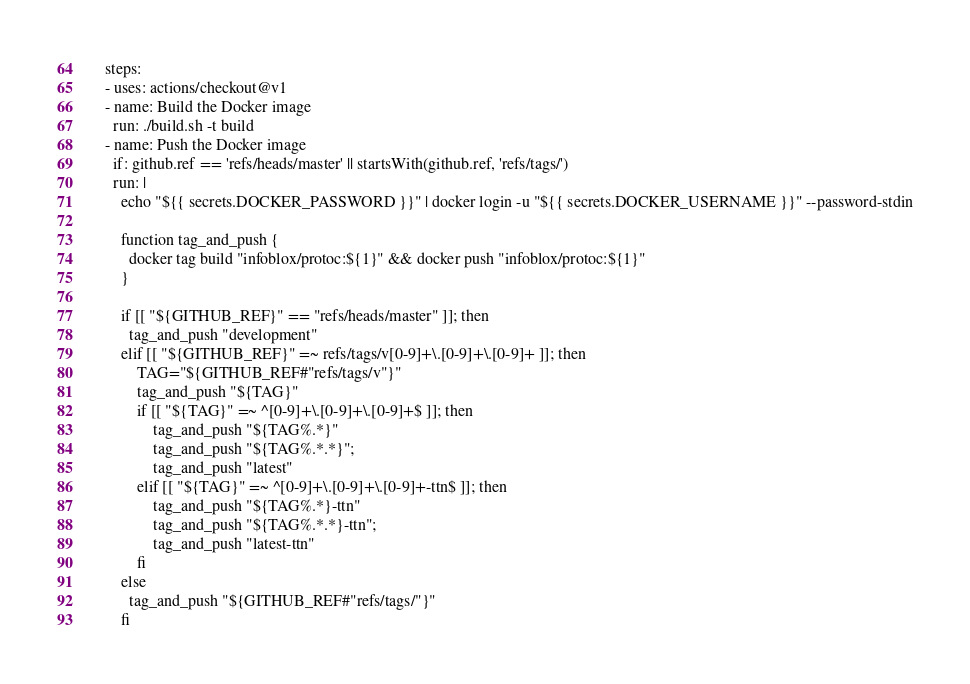<code> <loc_0><loc_0><loc_500><loc_500><_YAML_>    steps:
    - uses: actions/checkout@v1
    - name: Build the Docker image
      run: ./build.sh -t build
    - name: Push the Docker image
      if: github.ref == 'refs/heads/master' || startsWith(github.ref, 'refs/tags/')
      run: |
        echo "${{ secrets.DOCKER_PASSWORD }}" | docker login -u "${{ secrets.DOCKER_USERNAME }}" --password-stdin

        function tag_and_push {
          docker tag build "infoblox/protoc:${1}" && docker push "infoblox/protoc:${1}"
        }

        if [[ "${GITHUB_REF}" == "refs/heads/master" ]]; then
          tag_and_push "development"
        elif [[ "${GITHUB_REF}" =~ refs/tags/v[0-9]+\.[0-9]+\.[0-9]+ ]]; then
            TAG="${GITHUB_REF#"refs/tags/v"}"
            tag_and_push "${TAG}"
            if [[ "${TAG}" =~ ^[0-9]+\.[0-9]+\.[0-9]+$ ]]; then
                tag_and_push "${TAG%.*}"
                tag_and_push "${TAG%.*.*}";
                tag_and_push "latest"
            elif [[ "${TAG}" =~ ^[0-9]+\.[0-9]+\.[0-9]+-ttn$ ]]; then
                tag_and_push "${TAG%.*}-ttn"
                tag_and_push "${TAG%.*.*}-ttn";
                tag_and_push "latest-ttn"
            fi
        else
          tag_and_push "${GITHUB_REF#"refs/tags/"}"
        fi
</code> 